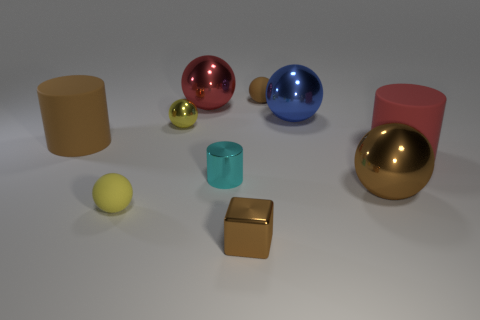Subtract 2 spheres. How many spheres are left? 4 Subtract all red balls. How many balls are left? 5 Subtract all red spheres. How many spheres are left? 5 Subtract all purple balls. Subtract all red blocks. How many balls are left? 6 Subtract all cylinders. How many objects are left? 7 Add 8 large rubber cylinders. How many large rubber cylinders exist? 10 Subtract 2 yellow spheres. How many objects are left? 8 Subtract all tiny green rubber cylinders. Subtract all big matte cylinders. How many objects are left? 8 Add 3 tiny yellow things. How many tiny yellow things are left? 5 